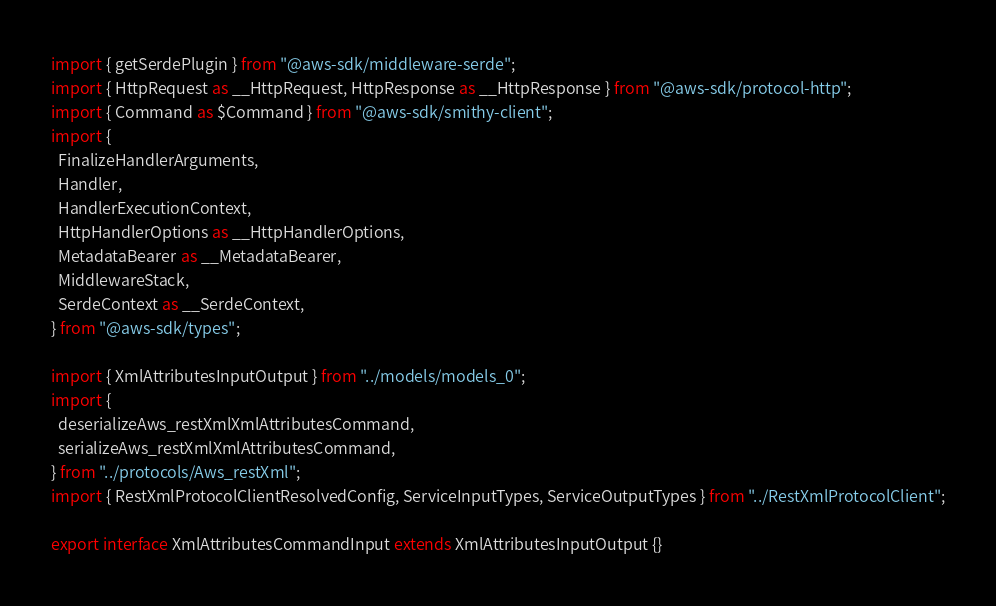Convert code to text. <code><loc_0><loc_0><loc_500><loc_500><_TypeScript_>import { getSerdePlugin } from "@aws-sdk/middleware-serde";
import { HttpRequest as __HttpRequest, HttpResponse as __HttpResponse } from "@aws-sdk/protocol-http";
import { Command as $Command } from "@aws-sdk/smithy-client";
import {
  FinalizeHandlerArguments,
  Handler,
  HandlerExecutionContext,
  HttpHandlerOptions as __HttpHandlerOptions,
  MetadataBearer as __MetadataBearer,
  MiddlewareStack,
  SerdeContext as __SerdeContext,
} from "@aws-sdk/types";

import { XmlAttributesInputOutput } from "../models/models_0";
import {
  deserializeAws_restXmlXmlAttributesCommand,
  serializeAws_restXmlXmlAttributesCommand,
} from "../protocols/Aws_restXml";
import { RestXmlProtocolClientResolvedConfig, ServiceInputTypes, ServiceOutputTypes } from "../RestXmlProtocolClient";

export interface XmlAttributesCommandInput extends XmlAttributesInputOutput {}</code> 